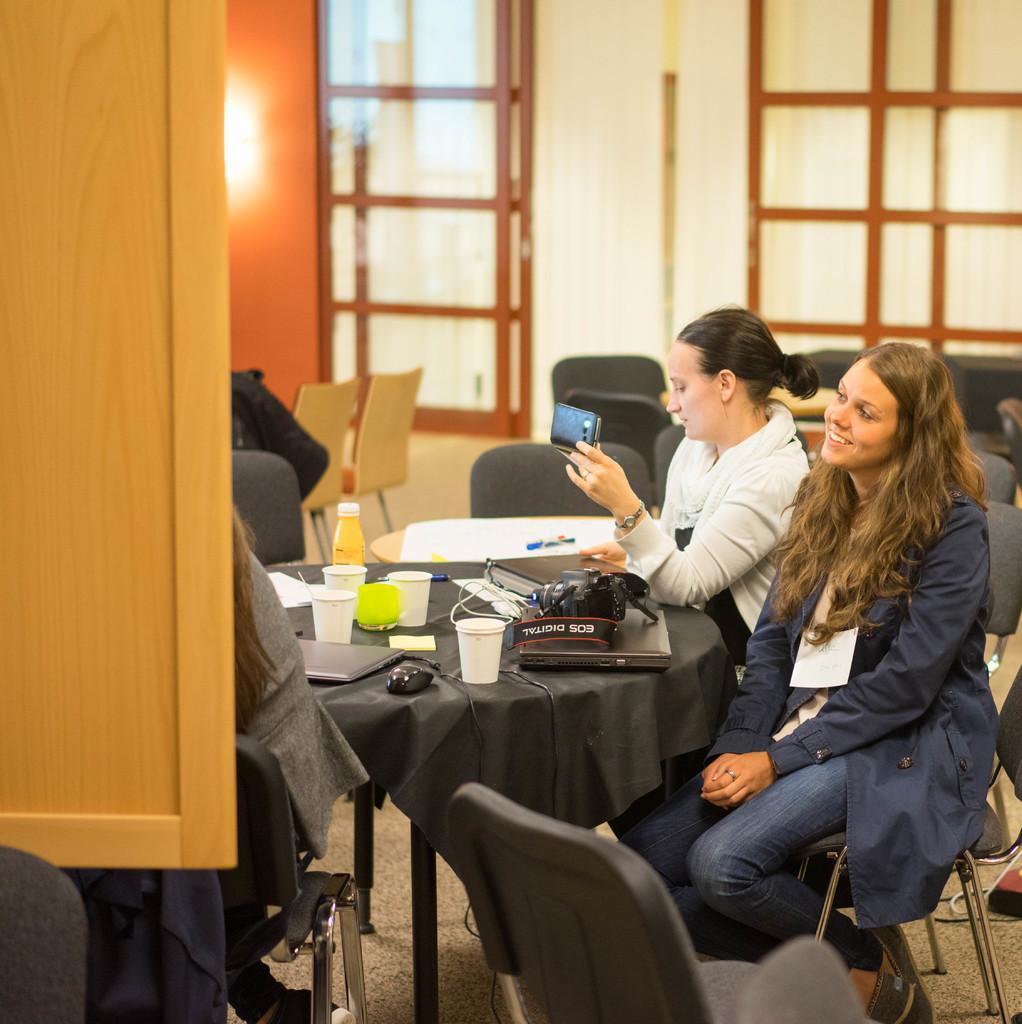Please provide a concise description of this image. people are sitting on the chairs across the table. on the table there are glasses, laptop, mouse,bottle, paper , pen. person at the back is holding a phone in her hand. 